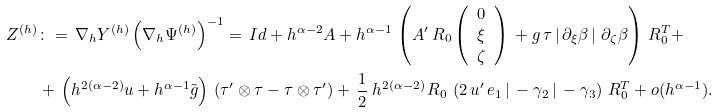Convert formula to latex. <formula><loc_0><loc_0><loc_500><loc_500>Z ^ { ( h ) } & \colon = \, \nabla _ { h } Y ^ { ( h ) } \left ( \nabla _ { h } \Psi ^ { ( h ) } \right ) ^ { - 1 } = \, I d + h ^ { \alpha - 2 } A + h ^ { \alpha - 1 } \, \left ( A ^ { \prime } \, R _ { 0 } \left ( \begin{array} { c } 0 \\ \xi \\ \zeta \end{array} \right ) \, + g \, \tau \left | \, \partial _ { \xi } \beta \, \right | \, \partial _ { \zeta } \beta \right ) \, R _ { 0 } ^ { T } + \\ & + \, \left ( h ^ { 2 ( \alpha - 2 ) } u + h ^ { \alpha - 1 } \tilde { g } \right ) \, \left ( \tau ^ { \prime } \otimes \tau - \tau \otimes \tau ^ { \prime } \right ) + \, \frac { 1 } { 2 } \, h ^ { 2 ( \alpha - 2 ) } \, R _ { 0 } \, \left ( 2 \, u ^ { \prime } \, e _ { 1 } \, | \, - \gamma _ { 2 } \, | \, - \gamma _ { 3 } \right ) \, R _ { 0 } ^ { T } + o ( h ^ { \alpha - 1 } ) .</formula> 